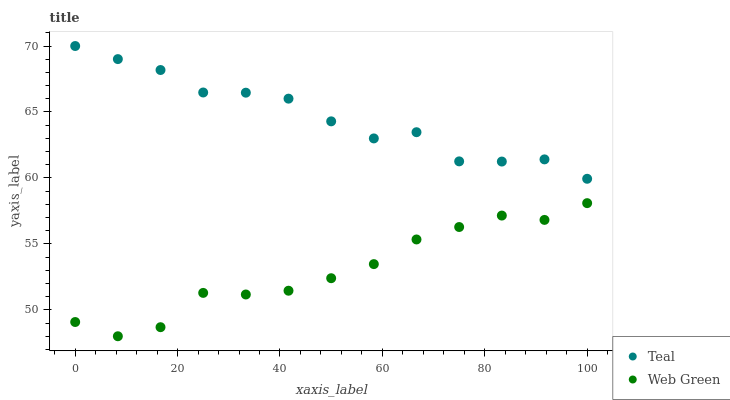Does Web Green have the minimum area under the curve?
Answer yes or no. Yes. Does Teal have the maximum area under the curve?
Answer yes or no. Yes. Does Teal have the minimum area under the curve?
Answer yes or no. No. Is Web Green the smoothest?
Answer yes or no. Yes. Is Teal the roughest?
Answer yes or no. Yes. Is Teal the smoothest?
Answer yes or no. No. Does Web Green have the lowest value?
Answer yes or no. Yes. Does Teal have the lowest value?
Answer yes or no. No. Does Teal have the highest value?
Answer yes or no. Yes. Is Web Green less than Teal?
Answer yes or no. Yes. Is Teal greater than Web Green?
Answer yes or no. Yes. Does Web Green intersect Teal?
Answer yes or no. No. 